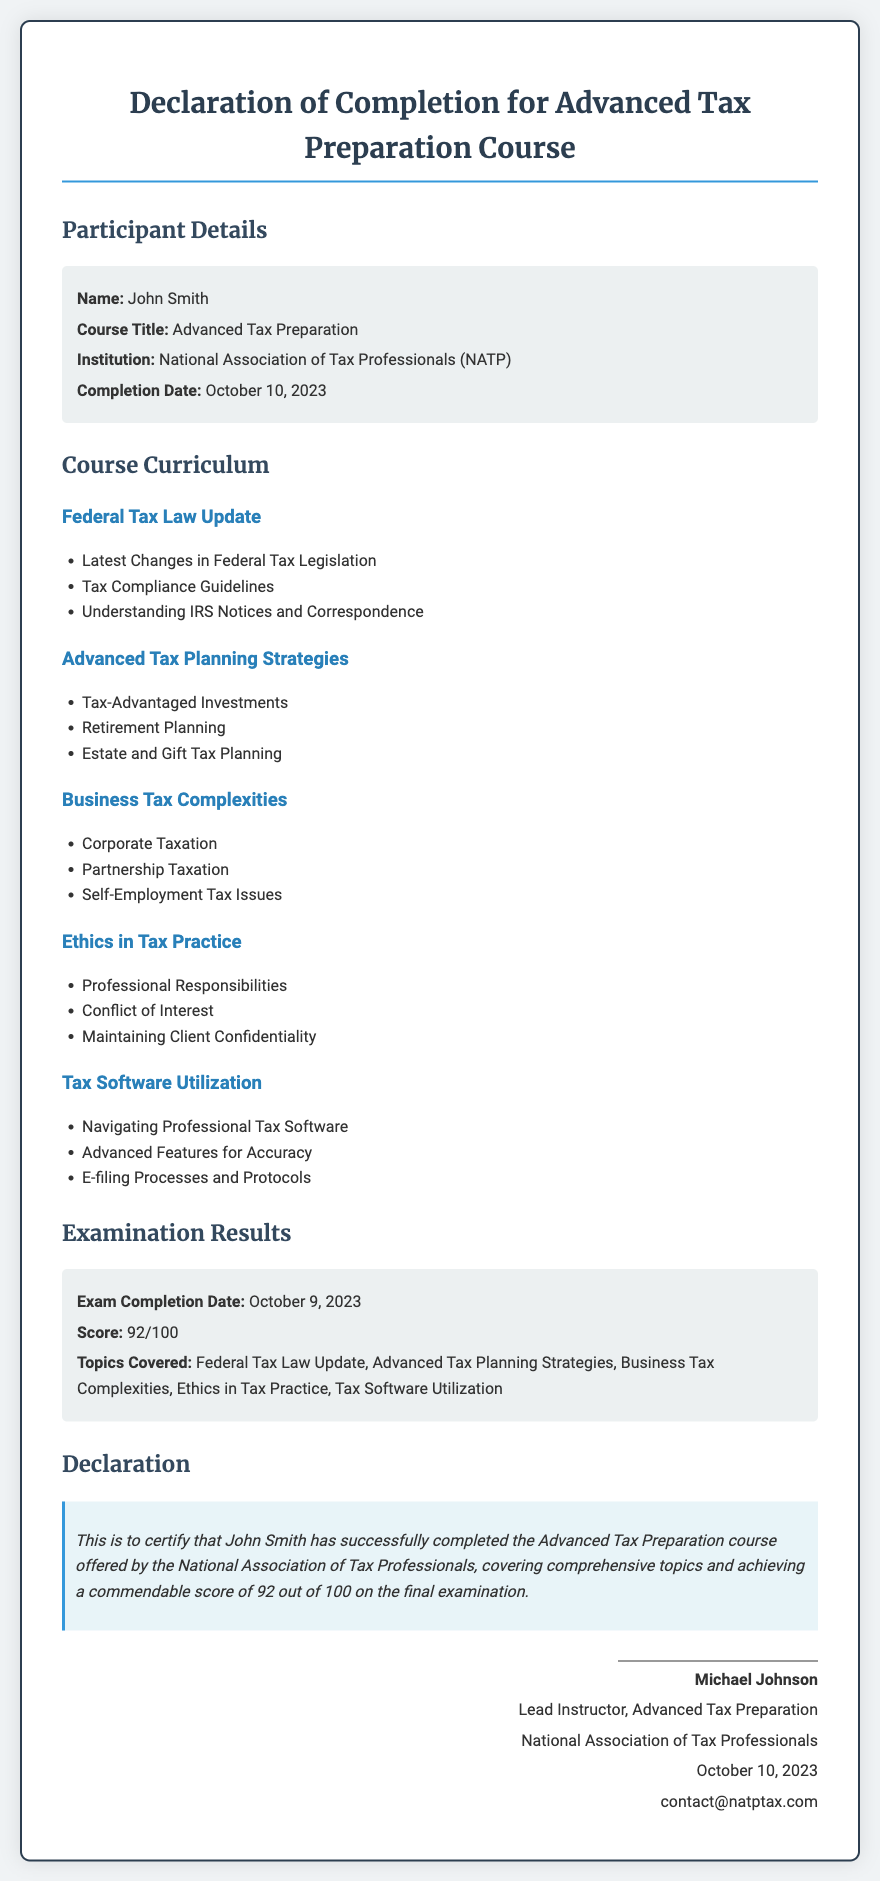What is the name of the participant? The name of the participant is explicitly mentioned in the details section of the document.
Answer: John Smith What is the completion date of the course? The completion date is provided in the details section and is a specific date.
Answer: October 10, 2023 What is the score achieved on the final examination? The score is noted under the Examination Results section and reflects the performance in numerical form.
Answer: 92/100 What institution offered the course? The institution is specified in the participant details area of the document.
Answer: National Association of Tax Professionals (NATP) How many modules are included in the course curriculum? The number of modules can be counted from the distinct headings listed in the curriculum section.
Answer: 5 Who is the lead instructor for the course? The name of the instructor is provided in the signature section at the end of the document.
Answer: Michael Johnson What type of examination topics are covered? The topics covered are listed directly under the Examination Results section, comprising various subjects.
Answer: Federal Tax Law Update, Advanced Tax Planning Strategies, Business Tax Complexities, Ethics in Tax Practice, Tax Software Utilization What is the primary purpose of this document? The purpose is explicitly stated in the declaration section of the document and indicates the completion of a specific course.
Answer: To certify completion of the Advanced Tax Preparation course What is the contact email provided at the end of the document? The contact email is found in the signature area and offers a direct line of communication for inquiries.
Answer: contact@natptax.com 